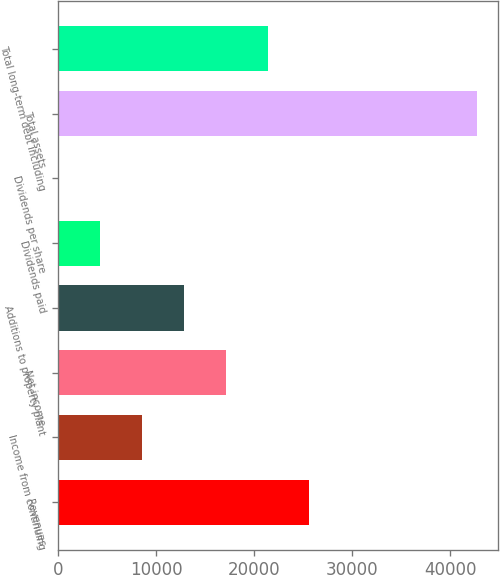Convert chart to OTSL. <chart><loc_0><loc_0><loc_500><loc_500><bar_chart><fcel>Revenues<fcel>Income from continuing<fcel>Net income<fcel>Additions to property plant<fcel>Dividends paid<fcel>Dividends per share<fcel>Total assets<fcel>Total long-term debt including<nl><fcel>25648<fcel>8549.94<fcel>17099<fcel>12824.5<fcel>4275.43<fcel>0.92<fcel>42746<fcel>21373.5<nl></chart> 